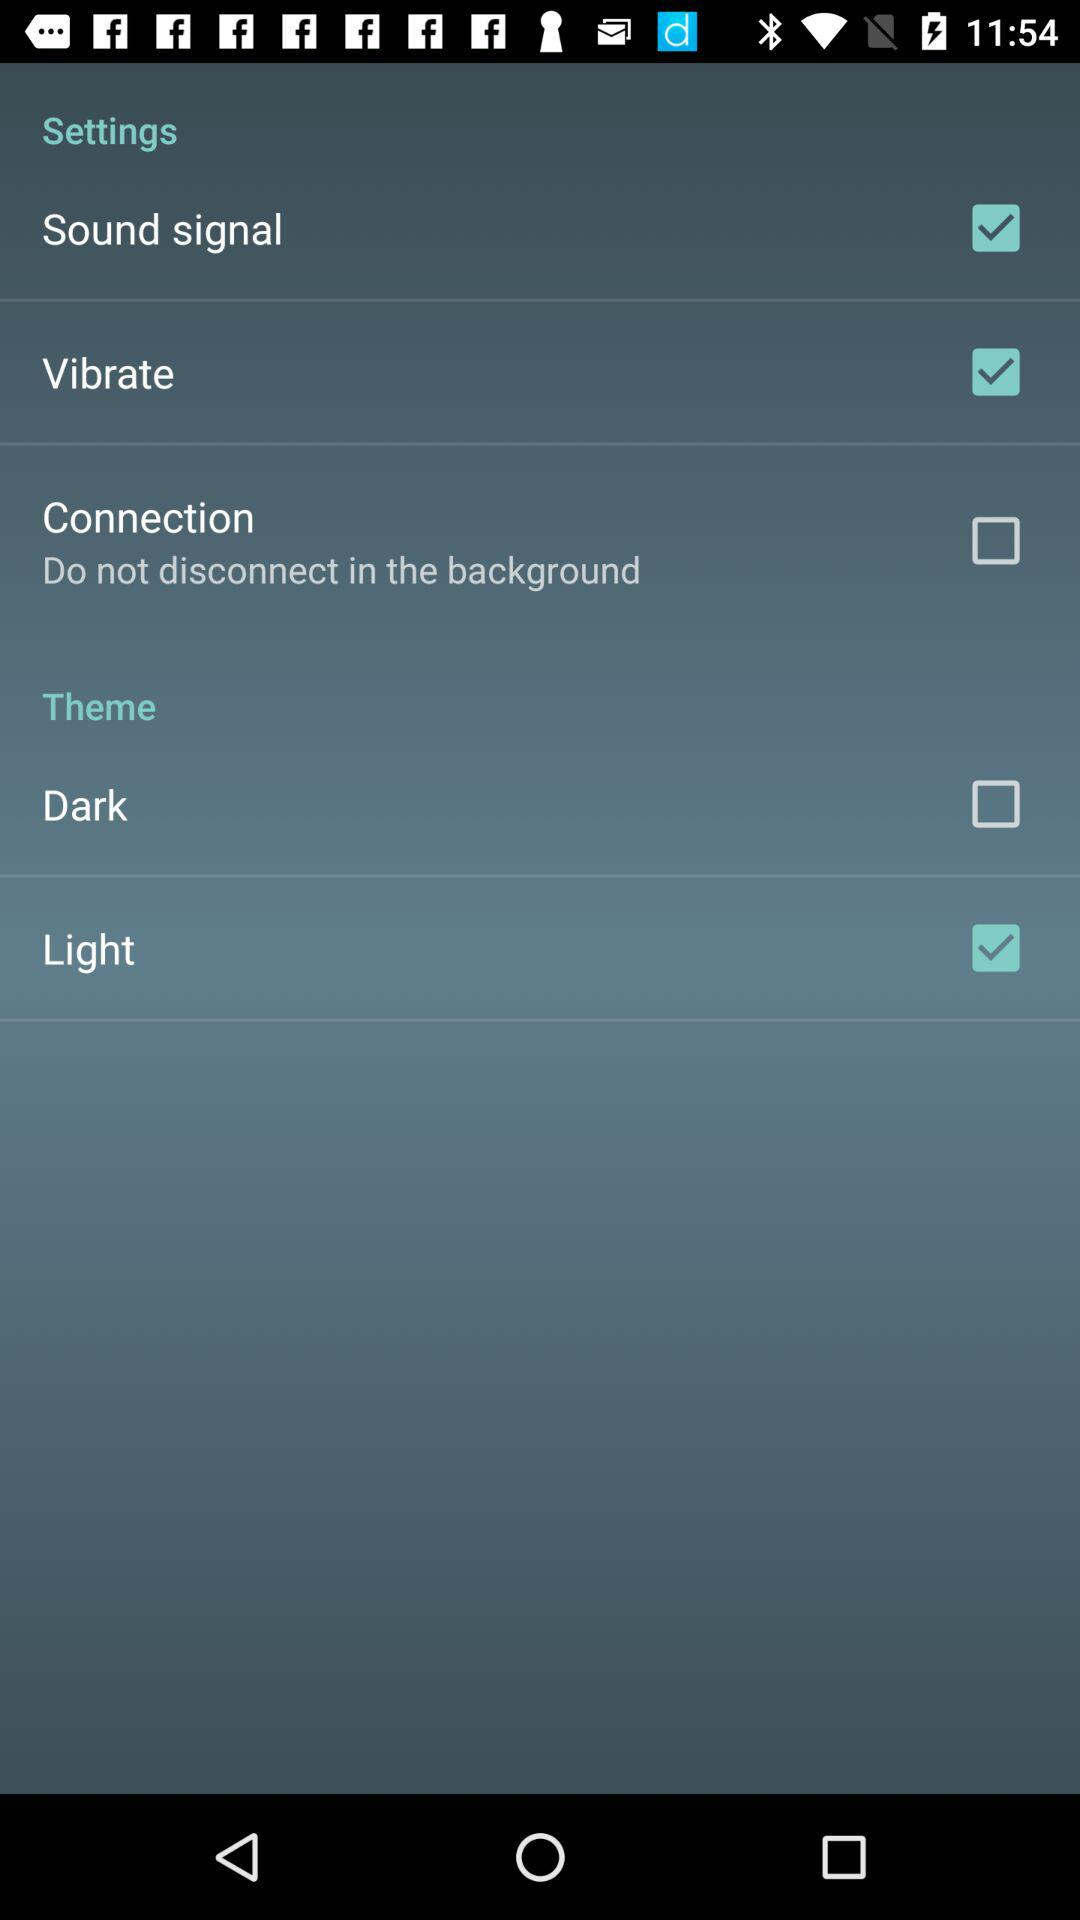Which type of theme has been selected? The selected theme is "Light". 